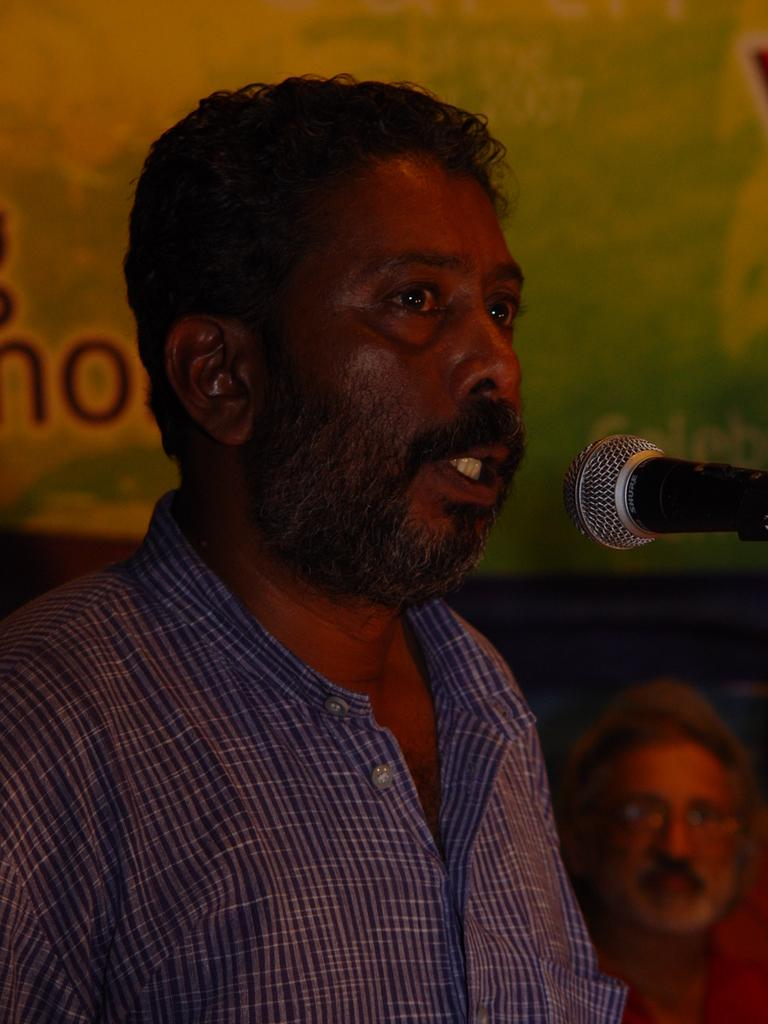Who is present in the picture? There is a man in the picture. What is the man wearing? The man is wearing a shirt. What object can be seen in the picture that is typically used for amplifying sound? There is a microphone in the picture. Can you describe the other person in the picture? There is another person in the picture, but no specific details are provided. What type of plant can be seen growing on the stage in the image? There is no plant or stage present in the image. How many clovers are visible on the man's shirt in the image? There is no mention of clovers on the man's shirt in the image. 